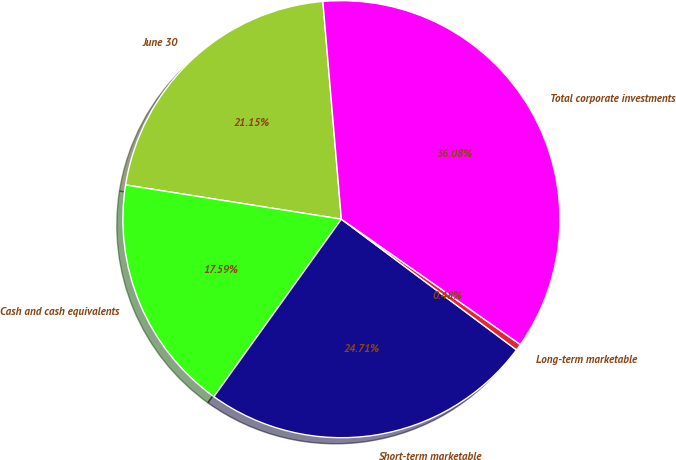Convert chart. <chart><loc_0><loc_0><loc_500><loc_500><pie_chart><fcel>June 30<fcel>Cash and cash equivalents<fcel>Short-term marketable<fcel>Long-term marketable<fcel>Total corporate investments<nl><fcel>21.15%<fcel>17.59%<fcel>24.71%<fcel>0.48%<fcel>36.08%<nl></chart> 